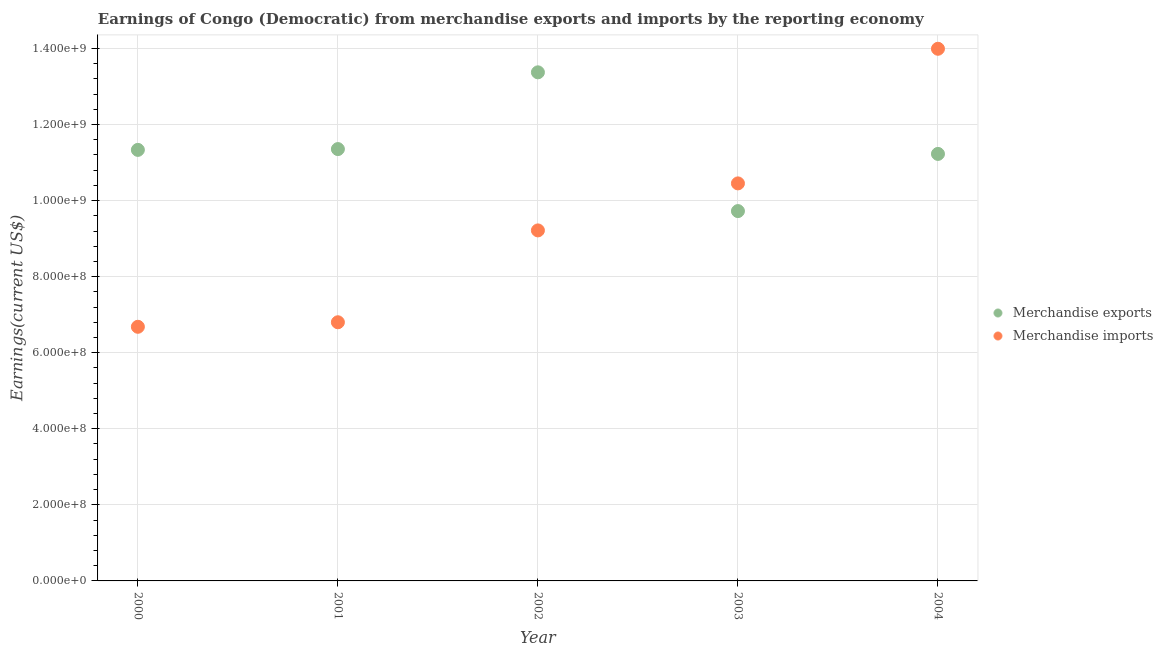Is the number of dotlines equal to the number of legend labels?
Offer a terse response. Yes. What is the earnings from merchandise imports in 2004?
Give a very brief answer. 1.40e+09. Across all years, what is the maximum earnings from merchandise exports?
Offer a terse response. 1.34e+09. Across all years, what is the minimum earnings from merchandise imports?
Keep it short and to the point. 6.68e+08. What is the total earnings from merchandise exports in the graph?
Offer a very short reply. 5.70e+09. What is the difference between the earnings from merchandise exports in 2000 and that in 2001?
Provide a short and direct response. -2.13e+06. What is the difference between the earnings from merchandise imports in 2003 and the earnings from merchandise exports in 2000?
Your answer should be compact. -8.81e+07. What is the average earnings from merchandise imports per year?
Your answer should be compact. 9.43e+08. In the year 2000, what is the difference between the earnings from merchandise exports and earnings from merchandise imports?
Your answer should be compact. 4.65e+08. In how many years, is the earnings from merchandise exports greater than 1000000000 US$?
Your response must be concise. 4. What is the ratio of the earnings from merchandise imports in 2002 to that in 2004?
Provide a succinct answer. 0.66. Is the difference between the earnings from merchandise exports in 2002 and 2004 greater than the difference between the earnings from merchandise imports in 2002 and 2004?
Your response must be concise. Yes. What is the difference between the highest and the second highest earnings from merchandise exports?
Your answer should be compact. 2.02e+08. What is the difference between the highest and the lowest earnings from merchandise exports?
Your response must be concise. 3.65e+08. Is the sum of the earnings from merchandise exports in 2000 and 2003 greater than the maximum earnings from merchandise imports across all years?
Your response must be concise. Yes. Is the earnings from merchandise imports strictly greater than the earnings from merchandise exports over the years?
Ensure brevity in your answer.  No. Is the earnings from merchandise exports strictly less than the earnings from merchandise imports over the years?
Your answer should be compact. No. How many dotlines are there?
Offer a very short reply. 2. How many years are there in the graph?
Your response must be concise. 5. What is the difference between two consecutive major ticks on the Y-axis?
Offer a terse response. 2.00e+08. Does the graph contain any zero values?
Provide a succinct answer. No. Does the graph contain grids?
Provide a succinct answer. Yes. Where does the legend appear in the graph?
Keep it short and to the point. Center right. How are the legend labels stacked?
Your response must be concise. Vertical. What is the title of the graph?
Your answer should be compact. Earnings of Congo (Democratic) from merchandise exports and imports by the reporting economy. Does "Banks" appear as one of the legend labels in the graph?
Make the answer very short. No. What is the label or title of the X-axis?
Your response must be concise. Year. What is the label or title of the Y-axis?
Offer a very short reply. Earnings(current US$). What is the Earnings(current US$) in Merchandise exports in 2000?
Your response must be concise. 1.13e+09. What is the Earnings(current US$) of Merchandise imports in 2000?
Give a very brief answer. 6.68e+08. What is the Earnings(current US$) in Merchandise exports in 2001?
Offer a terse response. 1.14e+09. What is the Earnings(current US$) of Merchandise imports in 2001?
Offer a very short reply. 6.80e+08. What is the Earnings(current US$) of Merchandise exports in 2002?
Give a very brief answer. 1.34e+09. What is the Earnings(current US$) in Merchandise imports in 2002?
Make the answer very short. 9.22e+08. What is the Earnings(current US$) in Merchandise exports in 2003?
Your answer should be compact. 9.72e+08. What is the Earnings(current US$) in Merchandise imports in 2003?
Your response must be concise. 1.05e+09. What is the Earnings(current US$) of Merchandise exports in 2004?
Keep it short and to the point. 1.12e+09. What is the Earnings(current US$) of Merchandise imports in 2004?
Ensure brevity in your answer.  1.40e+09. Across all years, what is the maximum Earnings(current US$) in Merchandise exports?
Provide a short and direct response. 1.34e+09. Across all years, what is the maximum Earnings(current US$) of Merchandise imports?
Make the answer very short. 1.40e+09. Across all years, what is the minimum Earnings(current US$) in Merchandise exports?
Ensure brevity in your answer.  9.72e+08. Across all years, what is the minimum Earnings(current US$) of Merchandise imports?
Your answer should be compact. 6.68e+08. What is the total Earnings(current US$) in Merchandise exports in the graph?
Your answer should be compact. 5.70e+09. What is the total Earnings(current US$) in Merchandise imports in the graph?
Give a very brief answer. 4.71e+09. What is the difference between the Earnings(current US$) of Merchandise exports in 2000 and that in 2001?
Provide a short and direct response. -2.13e+06. What is the difference between the Earnings(current US$) of Merchandise imports in 2000 and that in 2001?
Your response must be concise. -1.19e+07. What is the difference between the Earnings(current US$) in Merchandise exports in 2000 and that in 2002?
Keep it short and to the point. -2.04e+08. What is the difference between the Earnings(current US$) in Merchandise imports in 2000 and that in 2002?
Make the answer very short. -2.53e+08. What is the difference between the Earnings(current US$) in Merchandise exports in 2000 and that in 2003?
Ensure brevity in your answer.  1.61e+08. What is the difference between the Earnings(current US$) in Merchandise imports in 2000 and that in 2003?
Your answer should be very brief. -3.77e+08. What is the difference between the Earnings(current US$) in Merchandise exports in 2000 and that in 2004?
Your response must be concise. 1.06e+07. What is the difference between the Earnings(current US$) of Merchandise imports in 2000 and that in 2004?
Your answer should be very brief. -7.31e+08. What is the difference between the Earnings(current US$) of Merchandise exports in 2001 and that in 2002?
Your response must be concise. -2.02e+08. What is the difference between the Earnings(current US$) in Merchandise imports in 2001 and that in 2002?
Make the answer very short. -2.42e+08. What is the difference between the Earnings(current US$) in Merchandise exports in 2001 and that in 2003?
Your answer should be very brief. 1.63e+08. What is the difference between the Earnings(current US$) of Merchandise imports in 2001 and that in 2003?
Ensure brevity in your answer.  -3.65e+08. What is the difference between the Earnings(current US$) of Merchandise exports in 2001 and that in 2004?
Ensure brevity in your answer.  1.27e+07. What is the difference between the Earnings(current US$) in Merchandise imports in 2001 and that in 2004?
Provide a short and direct response. -7.19e+08. What is the difference between the Earnings(current US$) of Merchandise exports in 2002 and that in 2003?
Offer a terse response. 3.65e+08. What is the difference between the Earnings(current US$) in Merchandise imports in 2002 and that in 2003?
Make the answer very short. -1.24e+08. What is the difference between the Earnings(current US$) in Merchandise exports in 2002 and that in 2004?
Give a very brief answer. 2.14e+08. What is the difference between the Earnings(current US$) of Merchandise imports in 2002 and that in 2004?
Offer a terse response. -4.78e+08. What is the difference between the Earnings(current US$) in Merchandise exports in 2003 and that in 2004?
Keep it short and to the point. -1.50e+08. What is the difference between the Earnings(current US$) of Merchandise imports in 2003 and that in 2004?
Offer a terse response. -3.54e+08. What is the difference between the Earnings(current US$) in Merchandise exports in 2000 and the Earnings(current US$) in Merchandise imports in 2001?
Your answer should be compact. 4.53e+08. What is the difference between the Earnings(current US$) in Merchandise exports in 2000 and the Earnings(current US$) in Merchandise imports in 2002?
Offer a very short reply. 2.12e+08. What is the difference between the Earnings(current US$) in Merchandise exports in 2000 and the Earnings(current US$) in Merchandise imports in 2003?
Offer a very short reply. 8.81e+07. What is the difference between the Earnings(current US$) in Merchandise exports in 2000 and the Earnings(current US$) in Merchandise imports in 2004?
Provide a succinct answer. -2.66e+08. What is the difference between the Earnings(current US$) in Merchandise exports in 2001 and the Earnings(current US$) in Merchandise imports in 2002?
Provide a short and direct response. 2.14e+08. What is the difference between the Earnings(current US$) of Merchandise exports in 2001 and the Earnings(current US$) of Merchandise imports in 2003?
Ensure brevity in your answer.  9.02e+07. What is the difference between the Earnings(current US$) in Merchandise exports in 2001 and the Earnings(current US$) in Merchandise imports in 2004?
Provide a short and direct response. -2.64e+08. What is the difference between the Earnings(current US$) in Merchandise exports in 2002 and the Earnings(current US$) in Merchandise imports in 2003?
Make the answer very short. 2.92e+08. What is the difference between the Earnings(current US$) in Merchandise exports in 2002 and the Earnings(current US$) in Merchandise imports in 2004?
Ensure brevity in your answer.  -6.19e+07. What is the difference between the Earnings(current US$) of Merchandise exports in 2003 and the Earnings(current US$) of Merchandise imports in 2004?
Offer a terse response. -4.27e+08. What is the average Earnings(current US$) of Merchandise exports per year?
Offer a very short reply. 1.14e+09. What is the average Earnings(current US$) in Merchandise imports per year?
Make the answer very short. 9.43e+08. In the year 2000, what is the difference between the Earnings(current US$) in Merchandise exports and Earnings(current US$) in Merchandise imports?
Your answer should be very brief. 4.65e+08. In the year 2001, what is the difference between the Earnings(current US$) of Merchandise exports and Earnings(current US$) of Merchandise imports?
Your answer should be very brief. 4.55e+08. In the year 2002, what is the difference between the Earnings(current US$) of Merchandise exports and Earnings(current US$) of Merchandise imports?
Give a very brief answer. 4.16e+08. In the year 2003, what is the difference between the Earnings(current US$) of Merchandise exports and Earnings(current US$) of Merchandise imports?
Offer a terse response. -7.28e+07. In the year 2004, what is the difference between the Earnings(current US$) of Merchandise exports and Earnings(current US$) of Merchandise imports?
Your response must be concise. -2.76e+08. What is the ratio of the Earnings(current US$) of Merchandise imports in 2000 to that in 2001?
Provide a short and direct response. 0.98. What is the ratio of the Earnings(current US$) of Merchandise exports in 2000 to that in 2002?
Ensure brevity in your answer.  0.85. What is the ratio of the Earnings(current US$) in Merchandise imports in 2000 to that in 2002?
Offer a terse response. 0.72. What is the ratio of the Earnings(current US$) in Merchandise exports in 2000 to that in 2003?
Your answer should be very brief. 1.17. What is the ratio of the Earnings(current US$) of Merchandise imports in 2000 to that in 2003?
Provide a succinct answer. 0.64. What is the ratio of the Earnings(current US$) in Merchandise exports in 2000 to that in 2004?
Provide a succinct answer. 1.01. What is the ratio of the Earnings(current US$) of Merchandise imports in 2000 to that in 2004?
Your response must be concise. 0.48. What is the ratio of the Earnings(current US$) of Merchandise exports in 2001 to that in 2002?
Keep it short and to the point. 0.85. What is the ratio of the Earnings(current US$) in Merchandise imports in 2001 to that in 2002?
Your response must be concise. 0.74. What is the ratio of the Earnings(current US$) in Merchandise exports in 2001 to that in 2003?
Your answer should be compact. 1.17. What is the ratio of the Earnings(current US$) of Merchandise imports in 2001 to that in 2003?
Provide a succinct answer. 0.65. What is the ratio of the Earnings(current US$) in Merchandise exports in 2001 to that in 2004?
Make the answer very short. 1.01. What is the ratio of the Earnings(current US$) in Merchandise imports in 2001 to that in 2004?
Your answer should be very brief. 0.49. What is the ratio of the Earnings(current US$) in Merchandise exports in 2002 to that in 2003?
Keep it short and to the point. 1.38. What is the ratio of the Earnings(current US$) of Merchandise imports in 2002 to that in 2003?
Your answer should be compact. 0.88. What is the ratio of the Earnings(current US$) in Merchandise exports in 2002 to that in 2004?
Give a very brief answer. 1.19. What is the ratio of the Earnings(current US$) in Merchandise imports in 2002 to that in 2004?
Ensure brevity in your answer.  0.66. What is the ratio of the Earnings(current US$) of Merchandise exports in 2003 to that in 2004?
Provide a short and direct response. 0.87. What is the ratio of the Earnings(current US$) of Merchandise imports in 2003 to that in 2004?
Offer a terse response. 0.75. What is the difference between the highest and the second highest Earnings(current US$) in Merchandise exports?
Your answer should be compact. 2.02e+08. What is the difference between the highest and the second highest Earnings(current US$) of Merchandise imports?
Ensure brevity in your answer.  3.54e+08. What is the difference between the highest and the lowest Earnings(current US$) in Merchandise exports?
Make the answer very short. 3.65e+08. What is the difference between the highest and the lowest Earnings(current US$) of Merchandise imports?
Provide a short and direct response. 7.31e+08. 